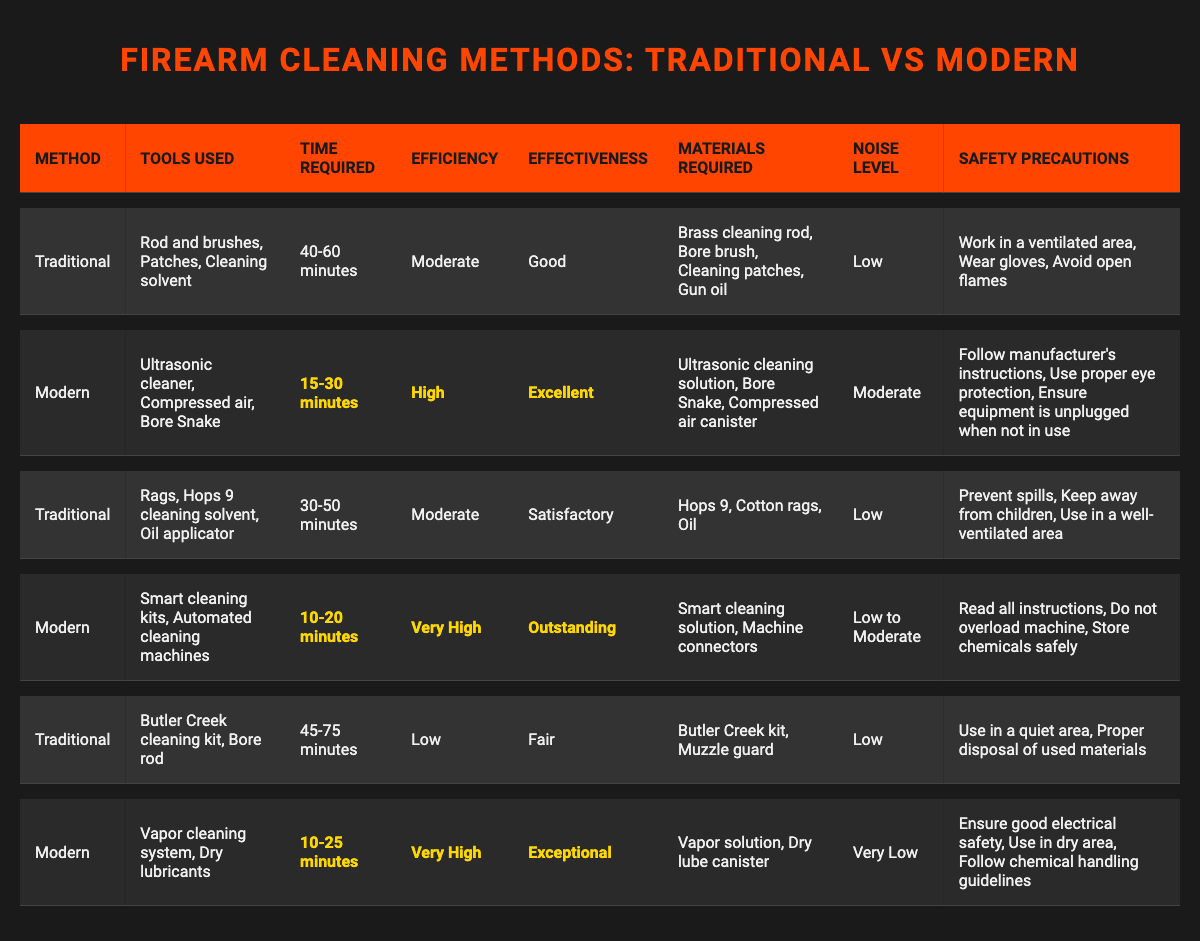What is the time required for modern cleaning methods? Three modern methods are listed with their respective time requirements: Ultrasonic cleaner (15-30 minutes), Smart cleaning kits (10-20 minutes), and Vapor cleaning system (10-25 minutes). The maximum time required is 30 minutes for the ultrasonic cleaner.
Answer: 30 minutes Which cleaning method is the most efficient? Comparing the efficiencies of the methods, "Smart cleaning kits" and "Vapor cleaning system" both have "Very High" efficiency, while "Ultrasonic cleaner" has "High" efficiency. Thus, "Smart cleaning kits" and "Vapor cleaning system" are the most efficient.
Answer: Smart cleaning kits and Vapor cleaning system What safety precaution is required for modern methods? Looking at modern cleaning methods, the safety precautions listed are: follow manufacturer's instructions, use proper eye protection, ensure equipment is unplugged when not in use for Ultrasonic cleaner; read all instructions, do not overload machine, store chemicals safely for Smart cleaning kits; and ensure good electrical safety, use in dry area, follow chemical handling guidelines for Vapor cleaning system.
Answer: Follow manufacturer's instructions Is the effectiveness of traditional methods always lower than that of modern methods? To check this, compare effectiveness ratings. Traditional methods have "Good," "Satisfactory," and "Fair" ratings, while modern methods have "Excellent," "Outstanding," and "Exceptional." All modern methods have higher effectiveness ratings than traditional methods.
Answer: Yes What is the average time required for traditional cleaning methods? The time required for traditional methods is 40-60 minutes, 30-50 minutes, and 45-75 minutes. To find the average, first calculate the ranges: (40+60)/2 = 50, (30+50)/2 = 40, (45+75)/2 = 60. The average of these three averages (50, 40, 60) is (50+40+60)/3 = 50 minutes.
Answer: 50 minutes How many traditional methods require more than an hour to clean? There are three traditional methods listed. Analyzing the time required, "Rod and brushes" (40-60 minutes), "Rags" (30-50 minutes), and "Butler Creek kit" (45-75 minutes) indicate that only "Butler Creek kit" takes more than an hour at maximum (75 minutes).
Answer: One traditional method Which modern cleaning method has the lowest noise level? The noise levels for modern methods are "Moderate" for ultrasonic cleaner, "Low to Moderate" for smart cleaning kits, and "Very Low" for vapor cleaning system. Thus, the modern cleaning method with the lowest noise level is the vapor cleaning system.
Answer: Vapor cleaning system Does using dry lubricants in modern methods introduce safety concerns? The vapor cleaning system states to ensure good electrical safety, using it in a dry area, and following chemical handling guidelines could indicate potential risks. However, safety precautions do not specify unique risks due to dry lubricants alone, pointing to general precautions rather than lubricant-specific concerns.
Answer: Not specifically, but general precautions apply What tools are used in the most effective cleaning method? The modern method with the highest effectiveness is "Vapor cleaning system" with "Exceptional" effectiveness. Its tools used are: Vapor cleaning system and Dry lubricants.
Answer: Vapor cleaning system and Dry lubricants 